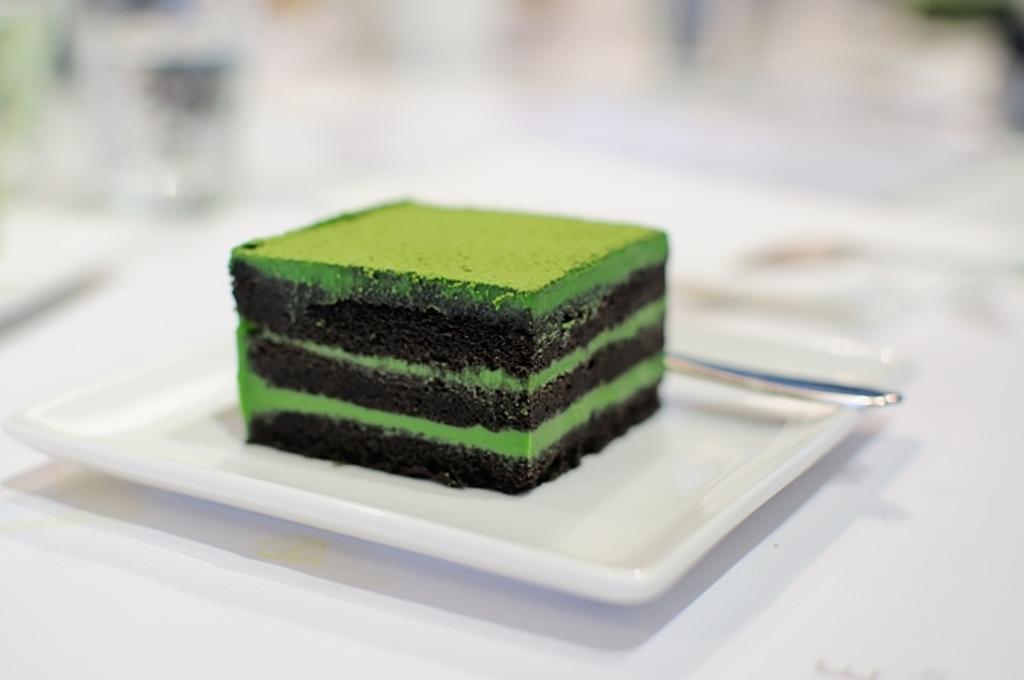Please provide a concise description of this image. In the image we can see a white surface, on it there is a plate square in shape and the plate is white in color. On the plate there is a slice of cake and a spoon and the background is blurred. 